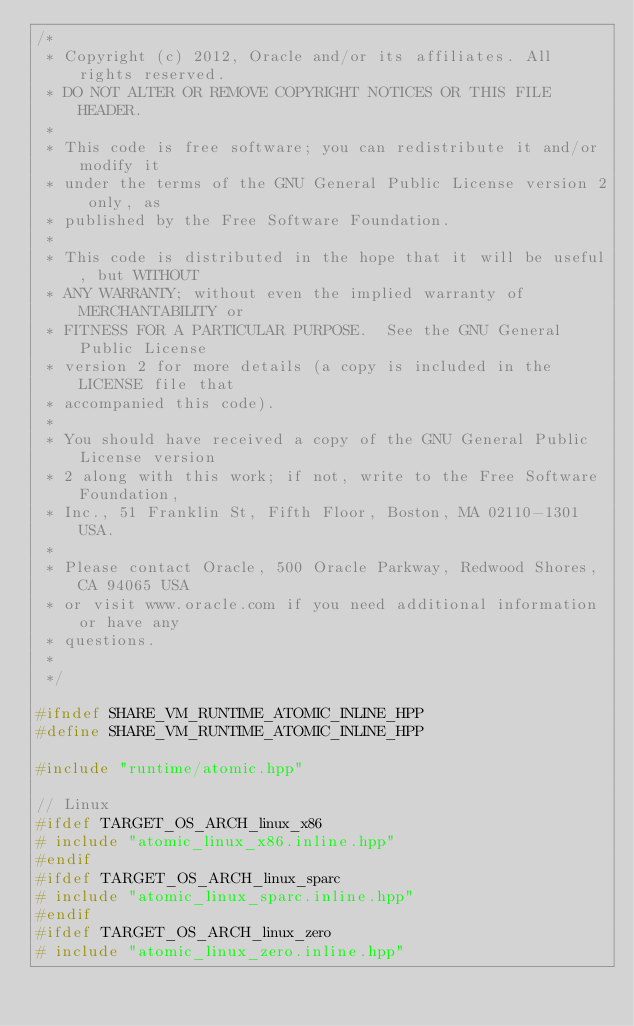<code> <loc_0><loc_0><loc_500><loc_500><_C++_>/*
 * Copyright (c) 2012, Oracle and/or its affiliates. All rights reserved.
 * DO NOT ALTER OR REMOVE COPYRIGHT NOTICES OR THIS FILE HEADER.
 *
 * This code is free software; you can redistribute it and/or modify it
 * under the terms of the GNU General Public License version 2 only, as
 * published by the Free Software Foundation.
 *
 * This code is distributed in the hope that it will be useful, but WITHOUT
 * ANY WARRANTY; without even the implied warranty of MERCHANTABILITY or
 * FITNESS FOR A PARTICULAR PURPOSE.  See the GNU General Public License
 * version 2 for more details (a copy is included in the LICENSE file that
 * accompanied this code).
 *
 * You should have received a copy of the GNU General Public License version
 * 2 along with this work; if not, write to the Free Software Foundation,
 * Inc., 51 Franklin St, Fifth Floor, Boston, MA 02110-1301 USA.
 *
 * Please contact Oracle, 500 Oracle Parkway, Redwood Shores, CA 94065 USA
 * or visit www.oracle.com if you need additional information or have any
 * questions.
 *
 */

#ifndef SHARE_VM_RUNTIME_ATOMIC_INLINE_HPP
#define SHARE_VM_RUNTIME_ATOMIC_INLINE_HPP

#include "runtime/atomic.hpp"

// Linux
#ifdef TARGET_OS_ARCH_linux_x86
# include "atomic_linux_x86.inline.hpp"
#endif
#ifdef TARGET_OS_ARCH_linux_sparc
# include "atomic_linux_sparc.inline.hpp"
#endif
#ifdef TARGET_OS_ARCH_linux_zero
# include "atomic_linux_zero.inline.hpp"</code> 